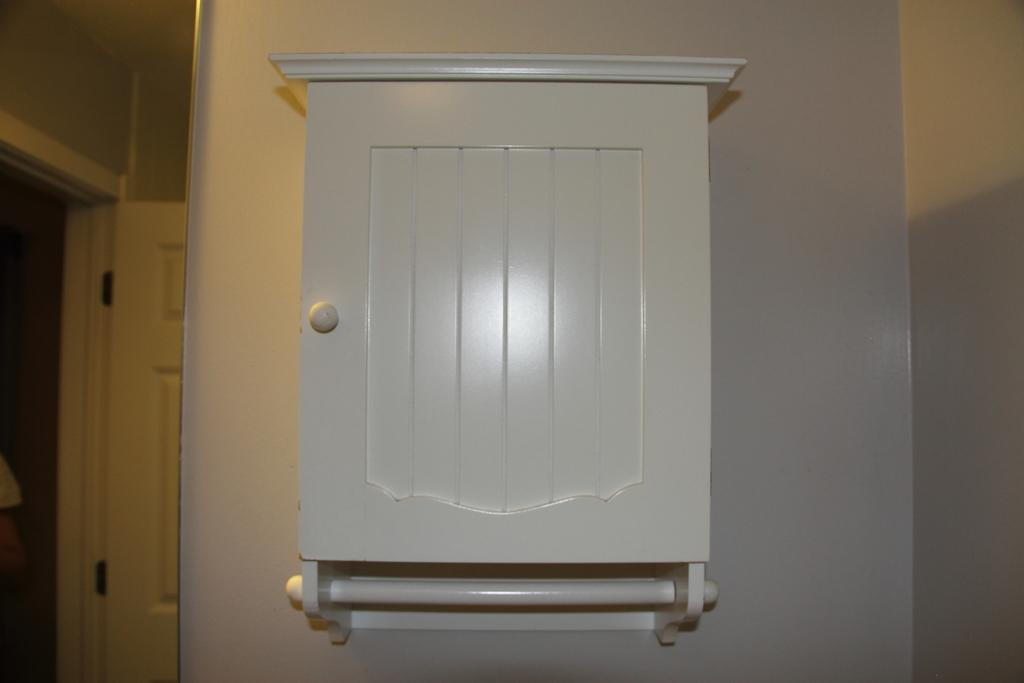What type of furniture is attached to the wall in the image? There is a cupboard attached to the wall in the image. Where is the cupboard located in relation to the image? The cupboard is on the right side of the image. What can be seen on the opposite side of the image? There is an open door on the left side of the image. Reasoning: Let's let's think step by step in order to produce the conversation. We start by identifying the main subject in the image, which is the cupboard attached to the wall. Then, we describe its location within the image. Finally, we mention the presence of an open door on the opposite side of the image, providing additional context. Absurd Question/Answer: Can you describe the beetle crawling on the waves during the journey in the image? There is no beetle, waves, or journey depicted in the image. The image only features a cupboard attached to the wall and an open door on the opposite side. 